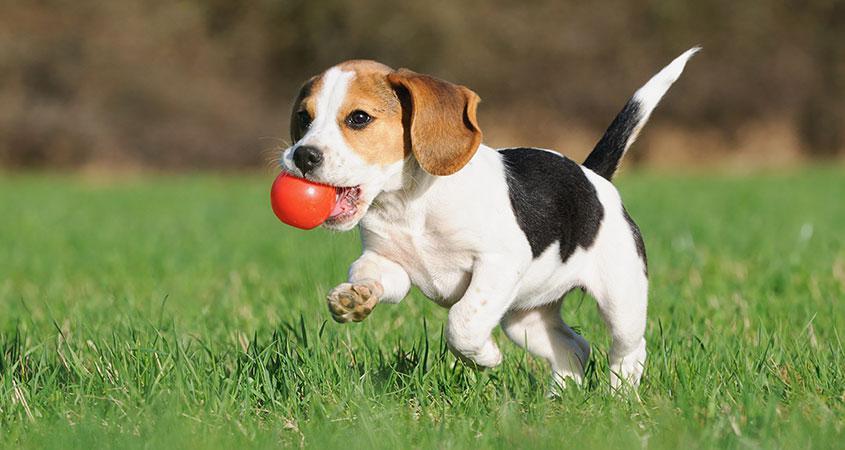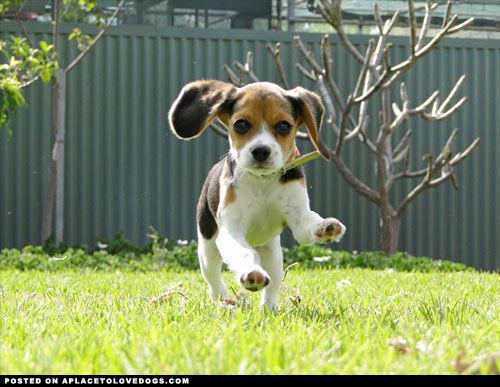The first image is the image on the left, the second image is the image on the right. Examine the images to the left and right. Is the description "An equal number of puppies are shown in each image at an outdoor location, one of them with its front paws in mid- air." accurate? Answer yes or no. Yes. The first image is the image on the left, the second image is the image on the right. Considering the images on both sides, is "There are equal amount of dogs in the left image as the right." valid? Answer yes or no. Yes. 